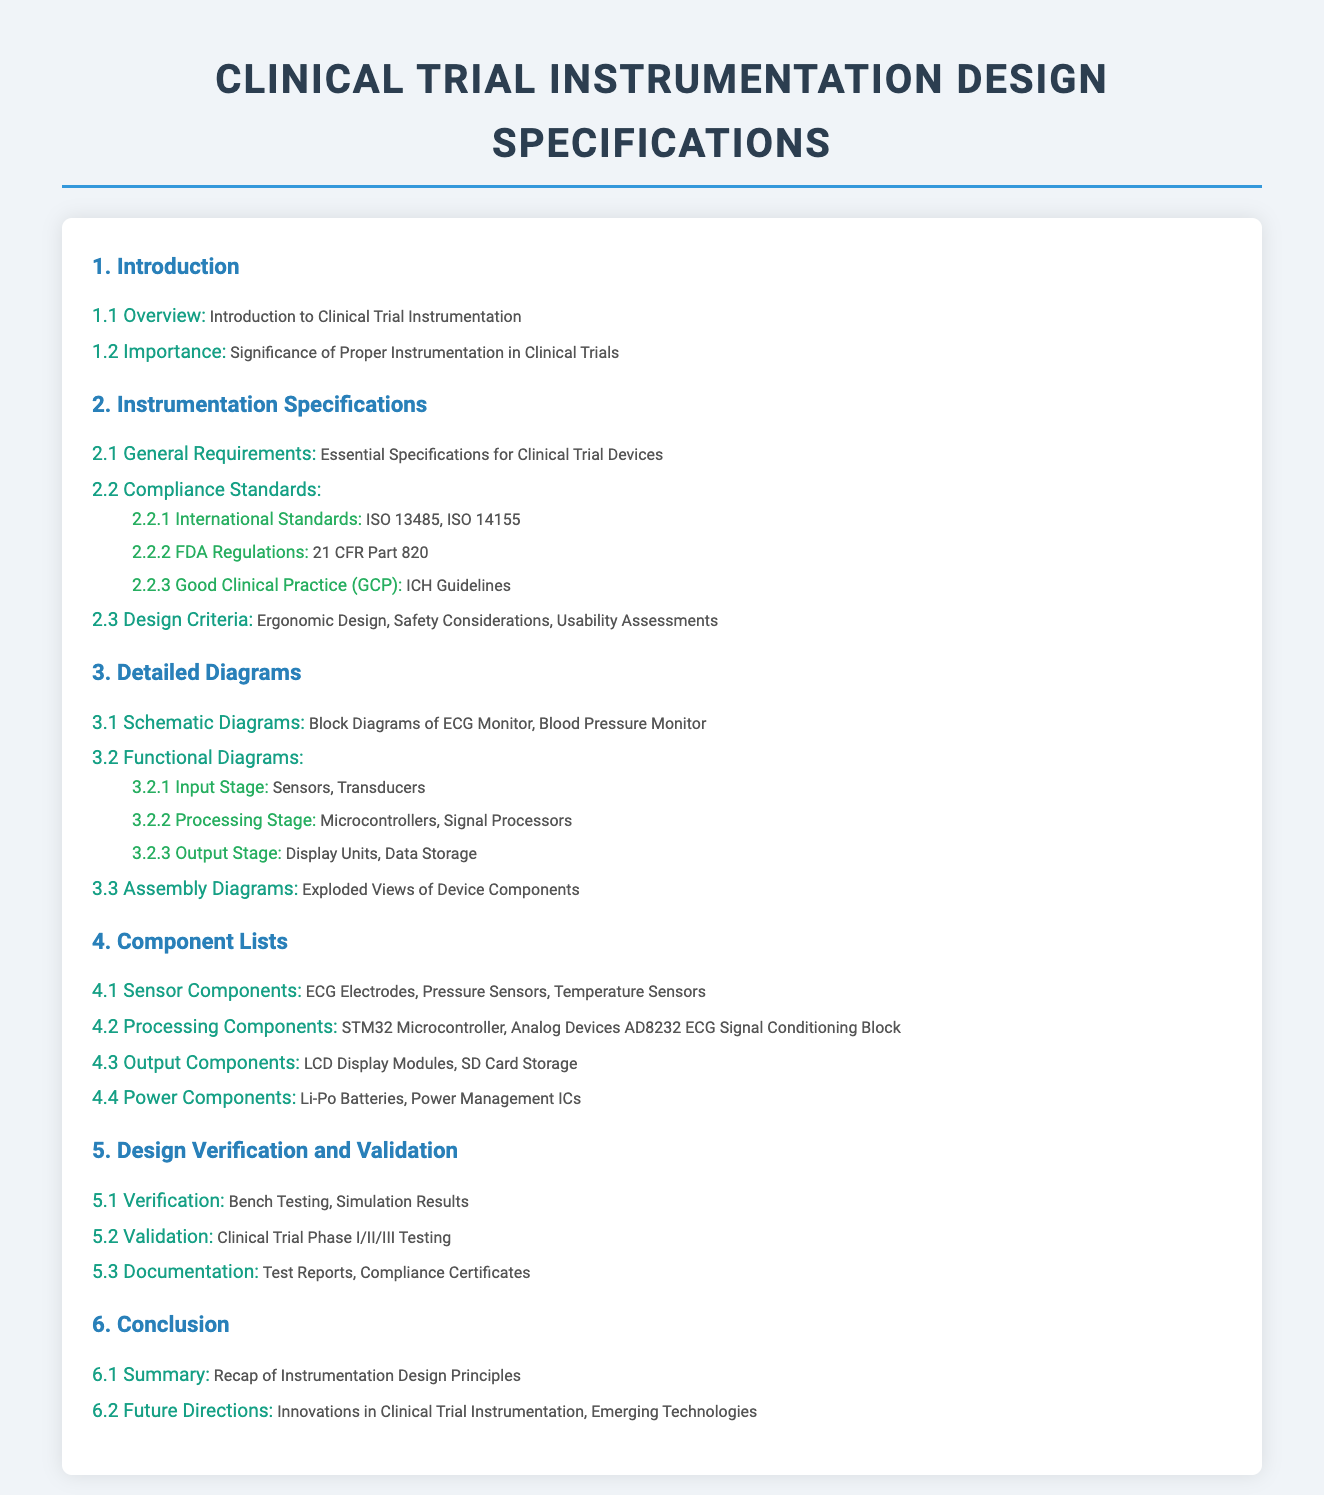What is the significance of proper instrumentation in clinical trials? This is mentioned in section 1.2, describing its importance in the effectiveness and reliability of trials.
Answer: Significance of Proper Instrumentation in Clinical Trials What international standards are referenced in the compliance section? These standards are listed in section 2.2.1, relating to quality management and clinical investigations.
Answer: ISO 13485, ISO 14155 Which microcontroller is specified in the processing components? This information is found in section 4.2, detailing components for processing.
Answer: STM32 Microcontroller How many testing phases are outlined for validation? This is in section 5.2, noting the various phases for clinical trial testing.
Answer: Three What essential specifications are required for clinical trial devices? This refers to section 2.1, detailing general requirements needed in the instrumentation design.
Answer: Essential Specifications for Clinical Trial Devices What type of diagrams are detailed in section 3? This addresses the specific content in section 3 regarding different diagram types.
Answer: Schematic Diagrams What are the future directions mentioned in the conclusion? It summarizes the content of section 6.2, discussing upcoming innovations and technologies.
Answer: Innovations in Clinical Trial Instrumentation, Emerging Technologies 